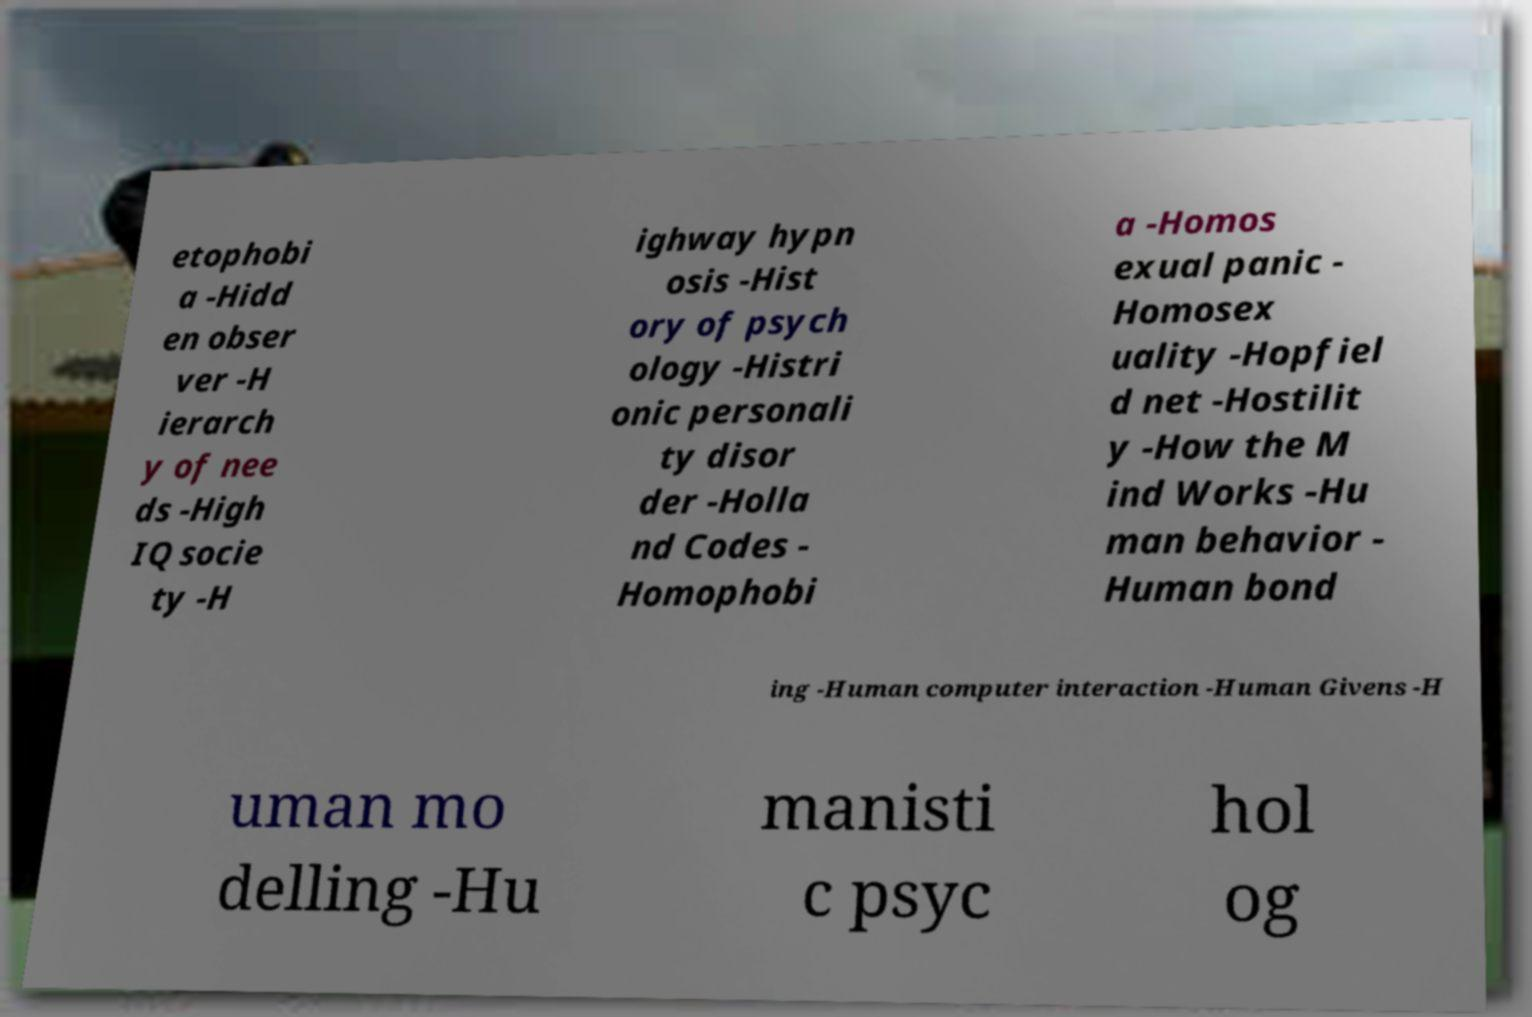Could you assist in decoding the text presented in this image and type it out clearly? etophobi a -Hidd en obser ver -H ierarch y of nee ds -High IQ socie ty -H ighway hypn osis -Hist ory of psych ology -Histri onic personali ty disor der -Holla nd Codes - Homophobi a -Homos exual panic - Homosex uality -Hopfiel d net -Hostilit y -How the M ind Works -Hu man behavior - Human bond ing -Human computer interaction -Human Givens -H uman mo delling -Hu manisti c psyc hol og 